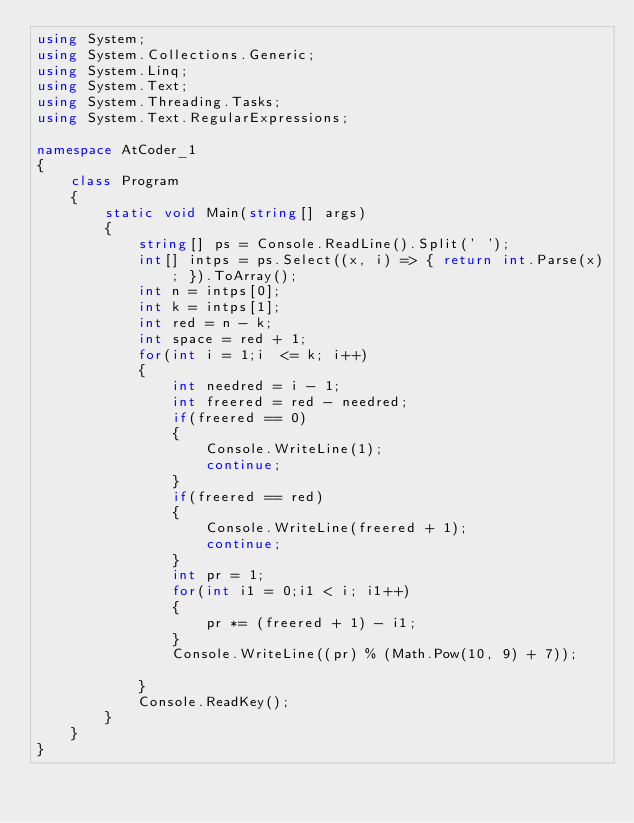<code> <loc_0><loc_0><loc_500><loc_500><_C#_>using System;
using System.Collections.Generic;
using System.Linq;
using System.Text;
using System.Threading.Tasks;
using System.Text.RegularExpressions;

namespace AtCoder_1
{
    class Program
    {
        static void Main(string[] args)
        {
            string[] ps = Console.ReadLine().Split(' ');
            int[] intps = ps.Select((x, i) => { return int.Parse(x); }).ToArray();
            int n = intps[0];
            int k = intps[1];
            int red = n - k;
            int space = red + 1;
            for(int i = 1;i  <= k; i++)
            {
                int needred = i - 1;
                int freered = red - needred;
                if(freered == 0)
                {
                    Console.WriteLine(1);
                    continue;
                }
                if(freered == red)
                {
                    Console.WriteLine(freered + 1);
                    continue;
                }
                int pr = 1;
                for(int i1 = 0;i1 < i; i1++)
                {
                    pr *= (freered + 1) - i1;
                }
                Console.WriteLine((pr) % (Math.Pow(10, 9) + 7));
               
            }
            Console.ReadKey();
        }
    }
}
</code> 